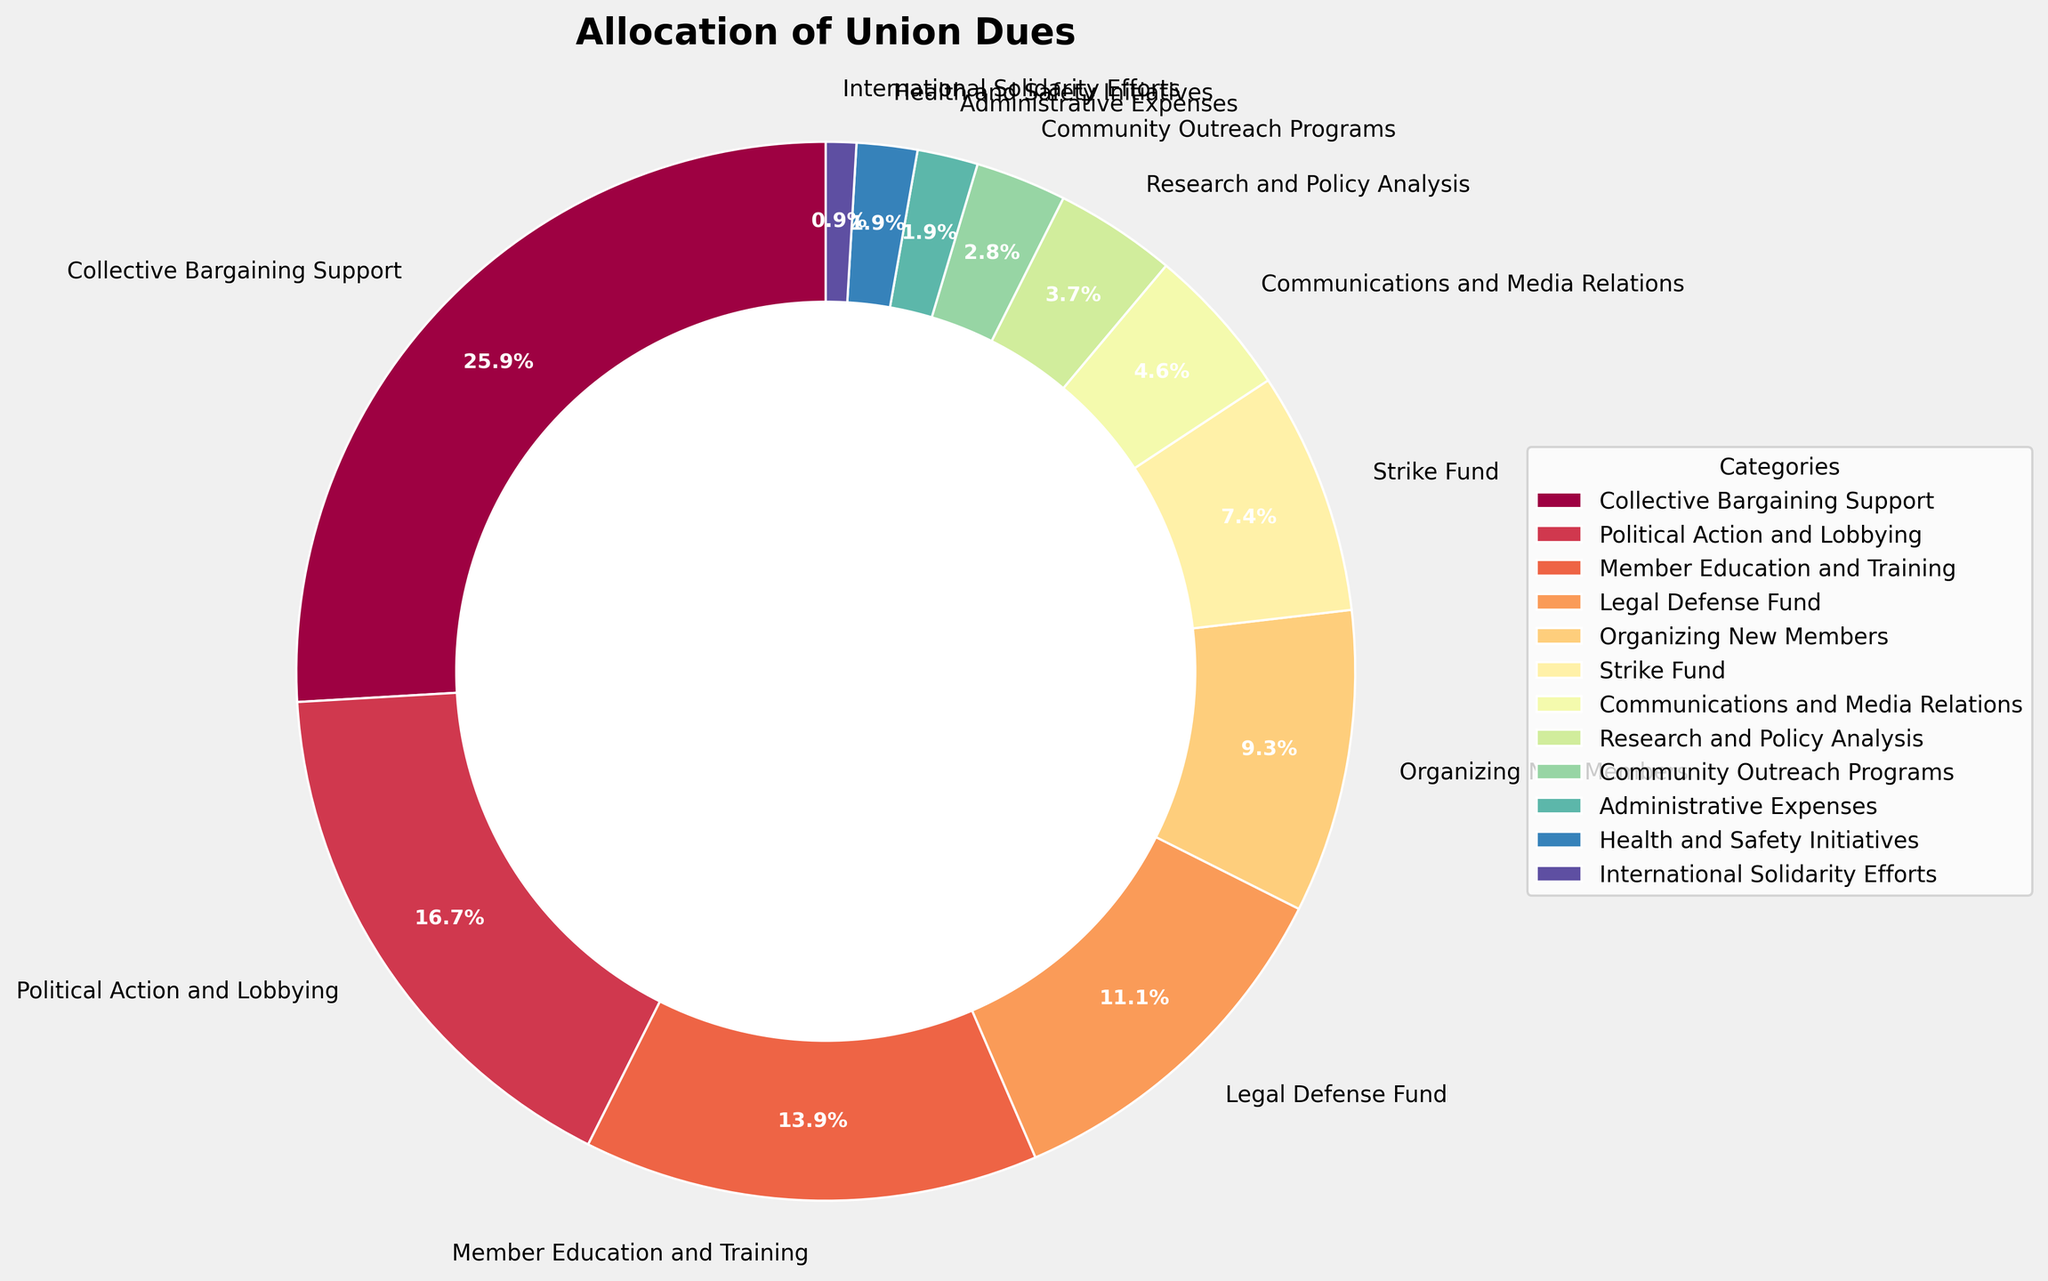Which category receives the most union dues? The wedge representing "Collective Bargaining Support" is the largest in the pie chart, indicating that it receives the highest percentage.
Answer: Collective Bargaining Support What is the combined percentage allocated to Member Education and Training, and Organizing New Members? To find the combined percentage, sum the percentages for "Member Education and Training" (15%) and "Organizing New Members" (10%). 15 + 10 equals 25.
Answer: 25% How much more is allocated to Political Action and Lobbying compared to Health and Safety Initiatives? The percentage for "Political Action and Lobbying" is 18%, and for "Health and Safety Initiatives," it is 2%. The difference is 18 - 2 equals 16.
Answer: 16% Which categories receive equal percentages of union dues? The categories "Administrative Expenses" and "Health and Safety Initiatives" both receive 2% of the union dues.
Answer: Administrative Expenses and Health and Safety Initiatives Is more union dues allocated to Strike Fund or Communications and Media Relations? By comparing the sizes of the wedges, "Strike Fund" with 8% is larger than "Communications and Media Relations" with 5%. So, more dues are allocated to the Strike Fund.
Answer: Strike Fund What is the total percentage allocated to categories that are directly related to worker support (e.g., Collective Bargaining Support, Legal Defense Fund, Strike Fund)? Add the percentages for "Collective Bargaining Support" (28%), "Legal Defense Fund" (12%), and "Strike Fund" (8%). 28 + 12 + 8 equals 48.
Answer: 48% Which category shows the least allocation of union dues? The wedge representing "International Solidarity Efforts" is the smallest in the pie chart with a percentage of 1%.
Answer: International Solidarity Efforts What are the three categories with the smallest allocation, and what is their total percentage? The smallest three allocations are "Administrative Expenses" (2%), "Health and Safety Initiatives" (2%), and "International Solidarity Efforts" (1%). Sum these to get the total: 2 + 2 + 1 equals 5.
Answer: Administrative Expenses, Health and Safety Initiatives, and International Solidarity Efforts; 5% How does the allocation for Research and Policy Analysis compare to that for Community Outreach Programs? Compare the sizes of the wedges: both "Research and Policy Analysis" and "Community Outreach Programs" have similar sizes. By examining the labels, both categories are allocated similar percentages, with "Research and Policy Analysis" at 4% and "Community Outreach Programs" at 3%.
Answer: Research and Policy Analysis is higher by 1% What's the average percentage allocated to Administrative Expenses and Health and Safety Initiatives? Add the percentages for "Administrative Expenses" (2%) and "Health and Safety Initiatives" (2%), then divide by 2. (2 + 2) / 2 equals 2.
Answer: 2% 